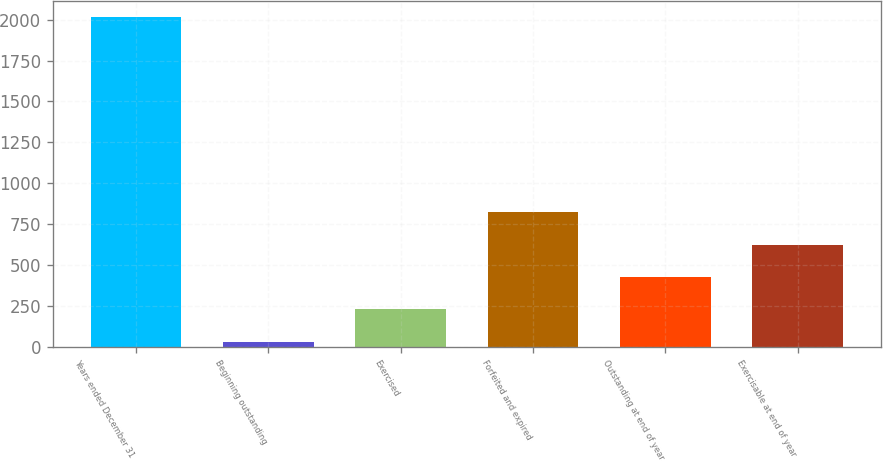Convert chart. <chart><loc_0><loc_0><loc_500><loc_500><bar_chart><fcel>Years ended December 31<fcel>Beginning outstanding<fcel>Exercised<fcel>Forfeited and expired<fcel>Outstanding at end of year<fcel>Exercisable at end of year<nl><fcel>2013<fcel>32<fcel>230.1<fcel>824.4<fcel>428.2<fcel>626.3<nl></chart> 